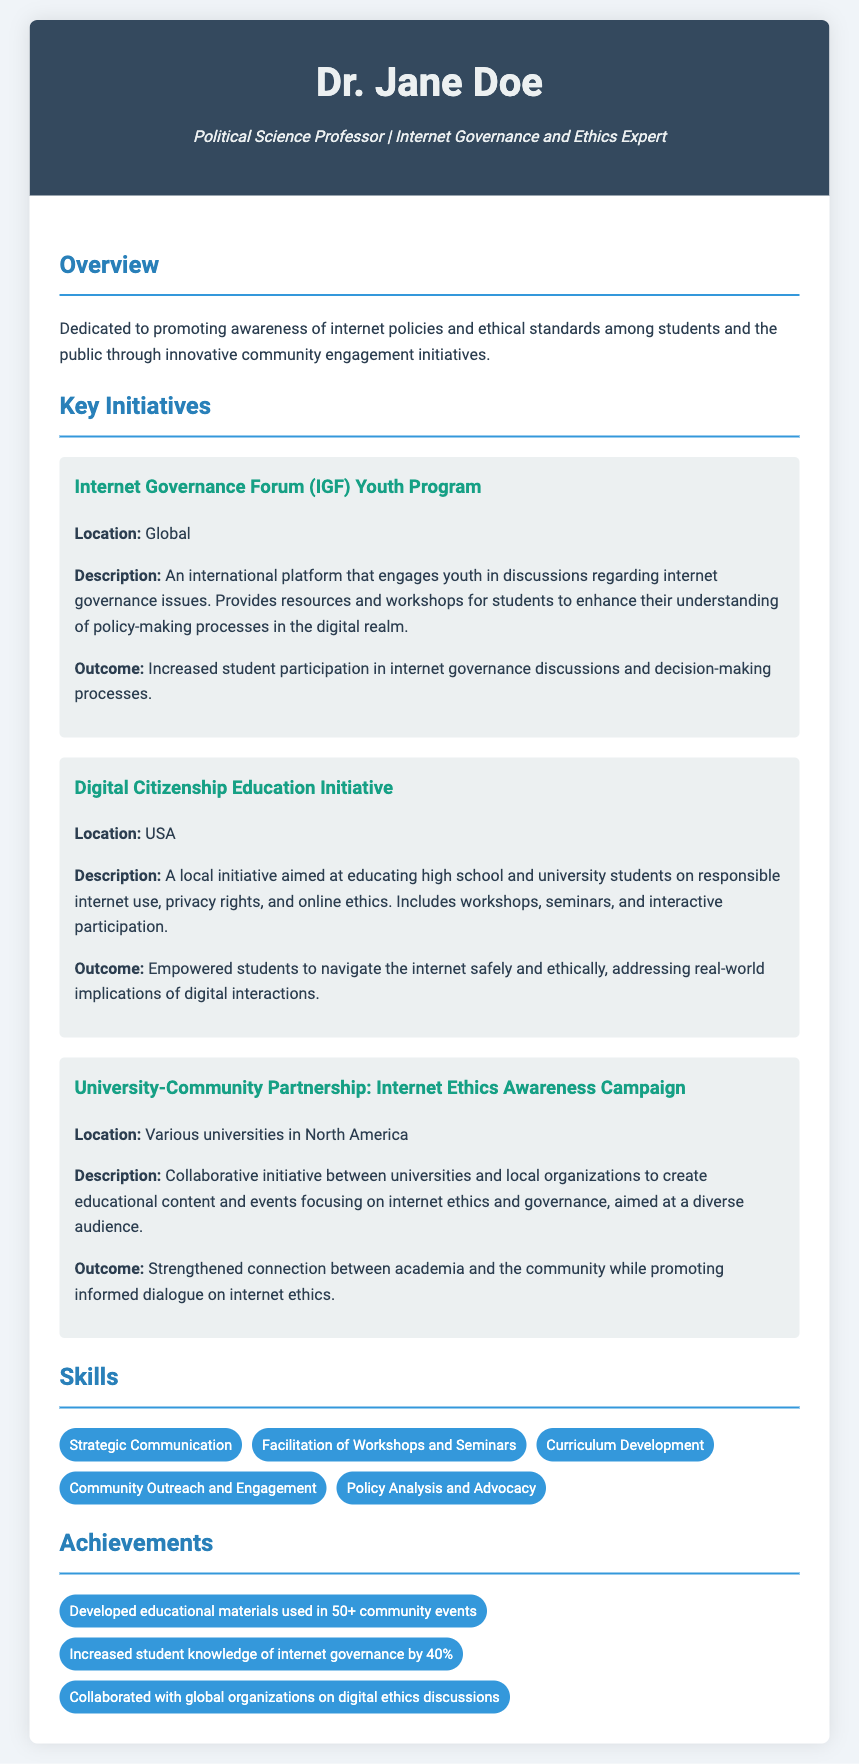What is the title of the document? The title of the document is indicated in the HTML as "Resume: Internet Governance and Ethics Expert."
Answer: Resume: Internet Governance and Ethics Expert Who is the author of the resume? The author is identified in the header section as "Dr. Jane Doe."
Answer: Dr. Jane Doe What is the goal of the initiatives mentioned in the overview? The overview specifies that the goal is to promote awareness of internet policies and ethical standards.
Answer: Promote awareness of internet policies and ethical standards How many key initiatives are listed in the document? The document details three initiatives under the "Key Initiatives" section.
Answer: Three What location is associated with the Digital Citizenship Education Initiative? The location for the Digital Citizenship Education Initiative is noted as "USA."
Answer: USA What was the outcome of the University-Community Partnership? The document states that the outcome was a "Strengthened connection between academia and the community."
Answer: Strengthened connection between academia and the community What skill related to outreach is mentioned? One of the skills highlighted is "Community Outreach and Engagement."
Answer: Community Outreach and Engagement How much did student knowledge of internet governance increase? The document notes an increase of "40%" in student knowledge.
Answer: 40% What type of content is developed through the University-Community Partnership? The partnership is focused on creating "educational content."
Answer: Educational content 